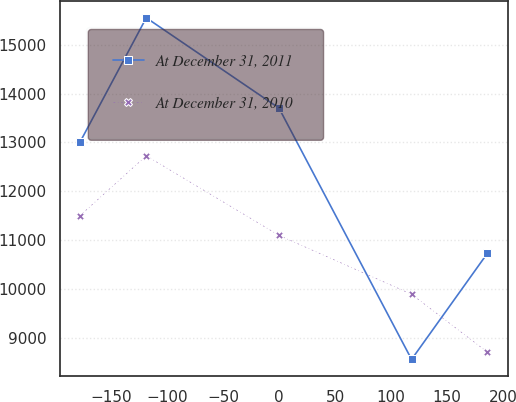Convert chart to OTSL. <chart><loc_0><loc_0><loc_500><loc_500><line_chart><ecel><fcel>At December 31, 2011<fcel>At December 31, 2010<nl><fcel>-177.52<fcel>13003.9<fcel>11502.5<nl><fcel>-118.34<fcel>15549.3<fcel>12728<nl><fcel>0<fcel>13702.5<fcel>11100.9<nl><fcel>118.24<fcel>8563.77<fcel>9896.19<nl><fcel>185.89<fcel>10734.5<fcel>8711.67<nl></chart> 